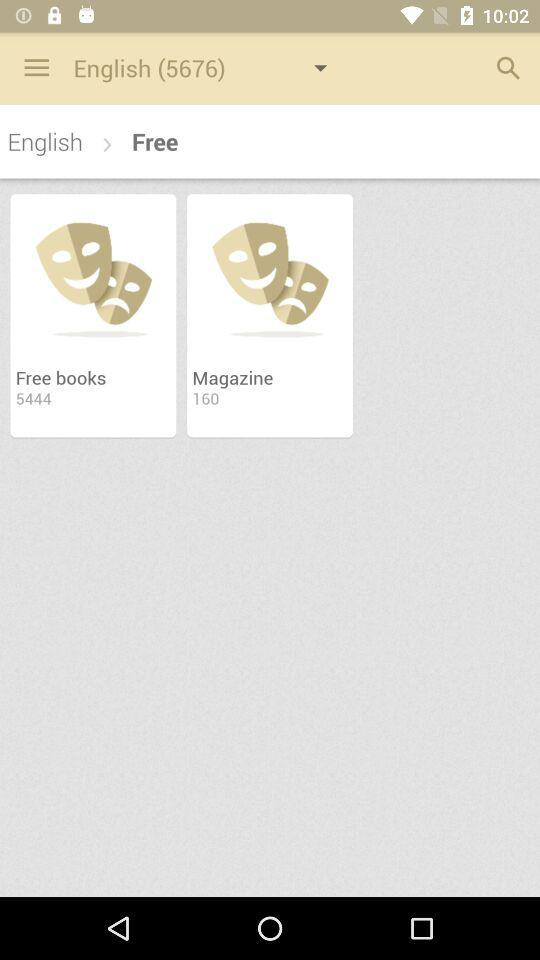How many free books are there? There are 5444 free books. 